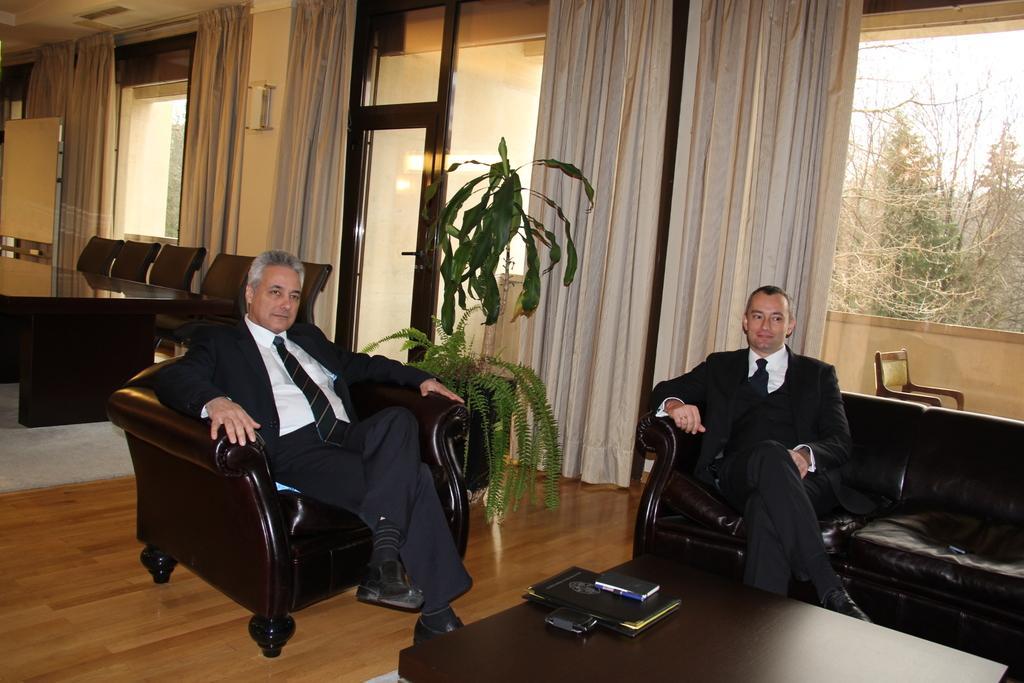Can you describe this image briefly? In this image we can see two men are sitting on black color sofa. They are wearing black color suits with white shirts. In front of them, table is present. On the table, we can see mobile and file. In the background, we can see dining table, chairs, windows, doors and curtains. Behind the window, dry trees are present and the sky is in white color. 